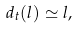<formula> <loc_0><loc_0><loc_500><loc_500>d _ { t } ( l ) \simeq l ,</formula> 